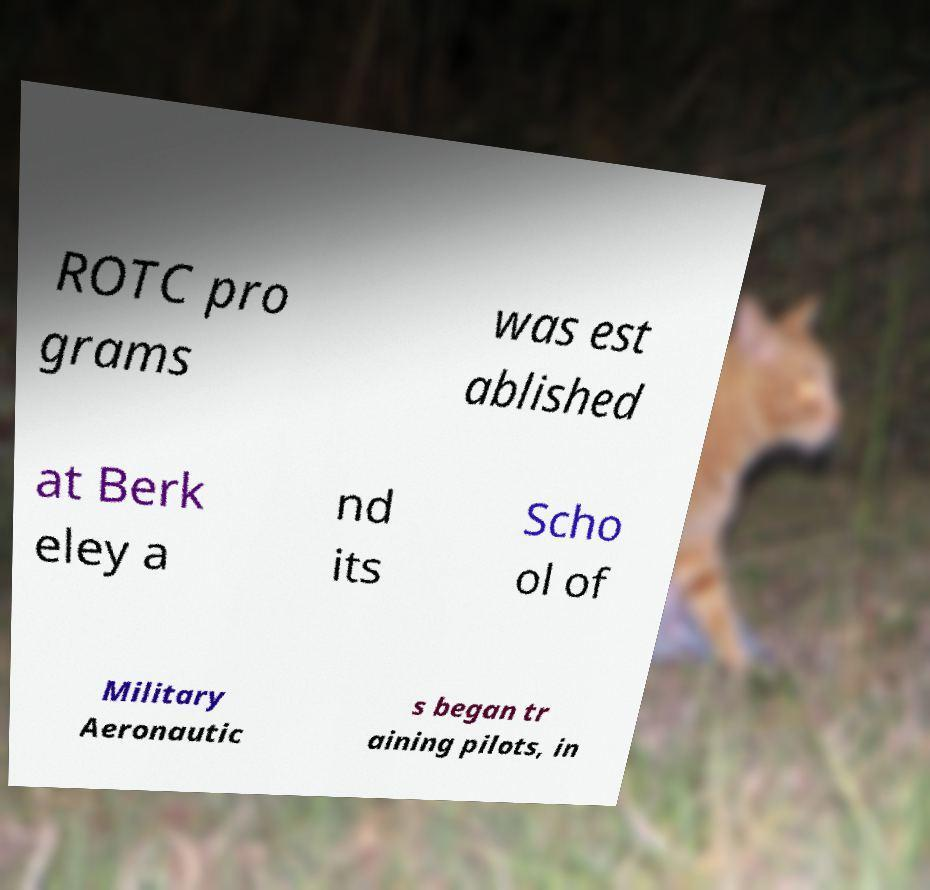Can you read and provide the text displayed in the image?This photo seems to have some interesting text. Can you extract and type it out for me? ROTC pro grams was est ablished at Berk eley a nd its Scho ol of Military Aeronautic s began tr aining pilots, in 